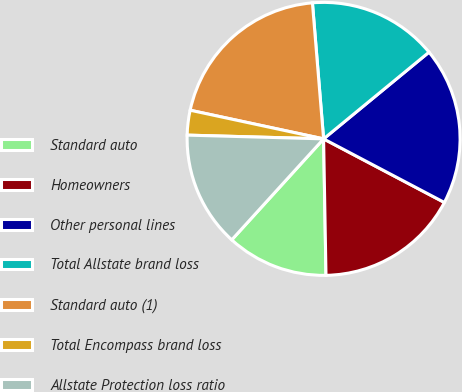Convert chart. <chart><loc_0><loc_0><loc_500><loc_500><pie_chart><fcel>Standard auto<fcel>Homeowners<fcel>Other personal lines<fcel>Total Allstate brand loss<fcel>Standard auto (1)<fcel>Total Encompass brand loss<fcel>Allstate Protection loss ratio<nl><fcel>12.03%<fcel>17.01%<fcel>18.67%<fcel>15.35%<fcel>20.33%<fcel>2.93%<fcel>13.69%<nl></chart> 